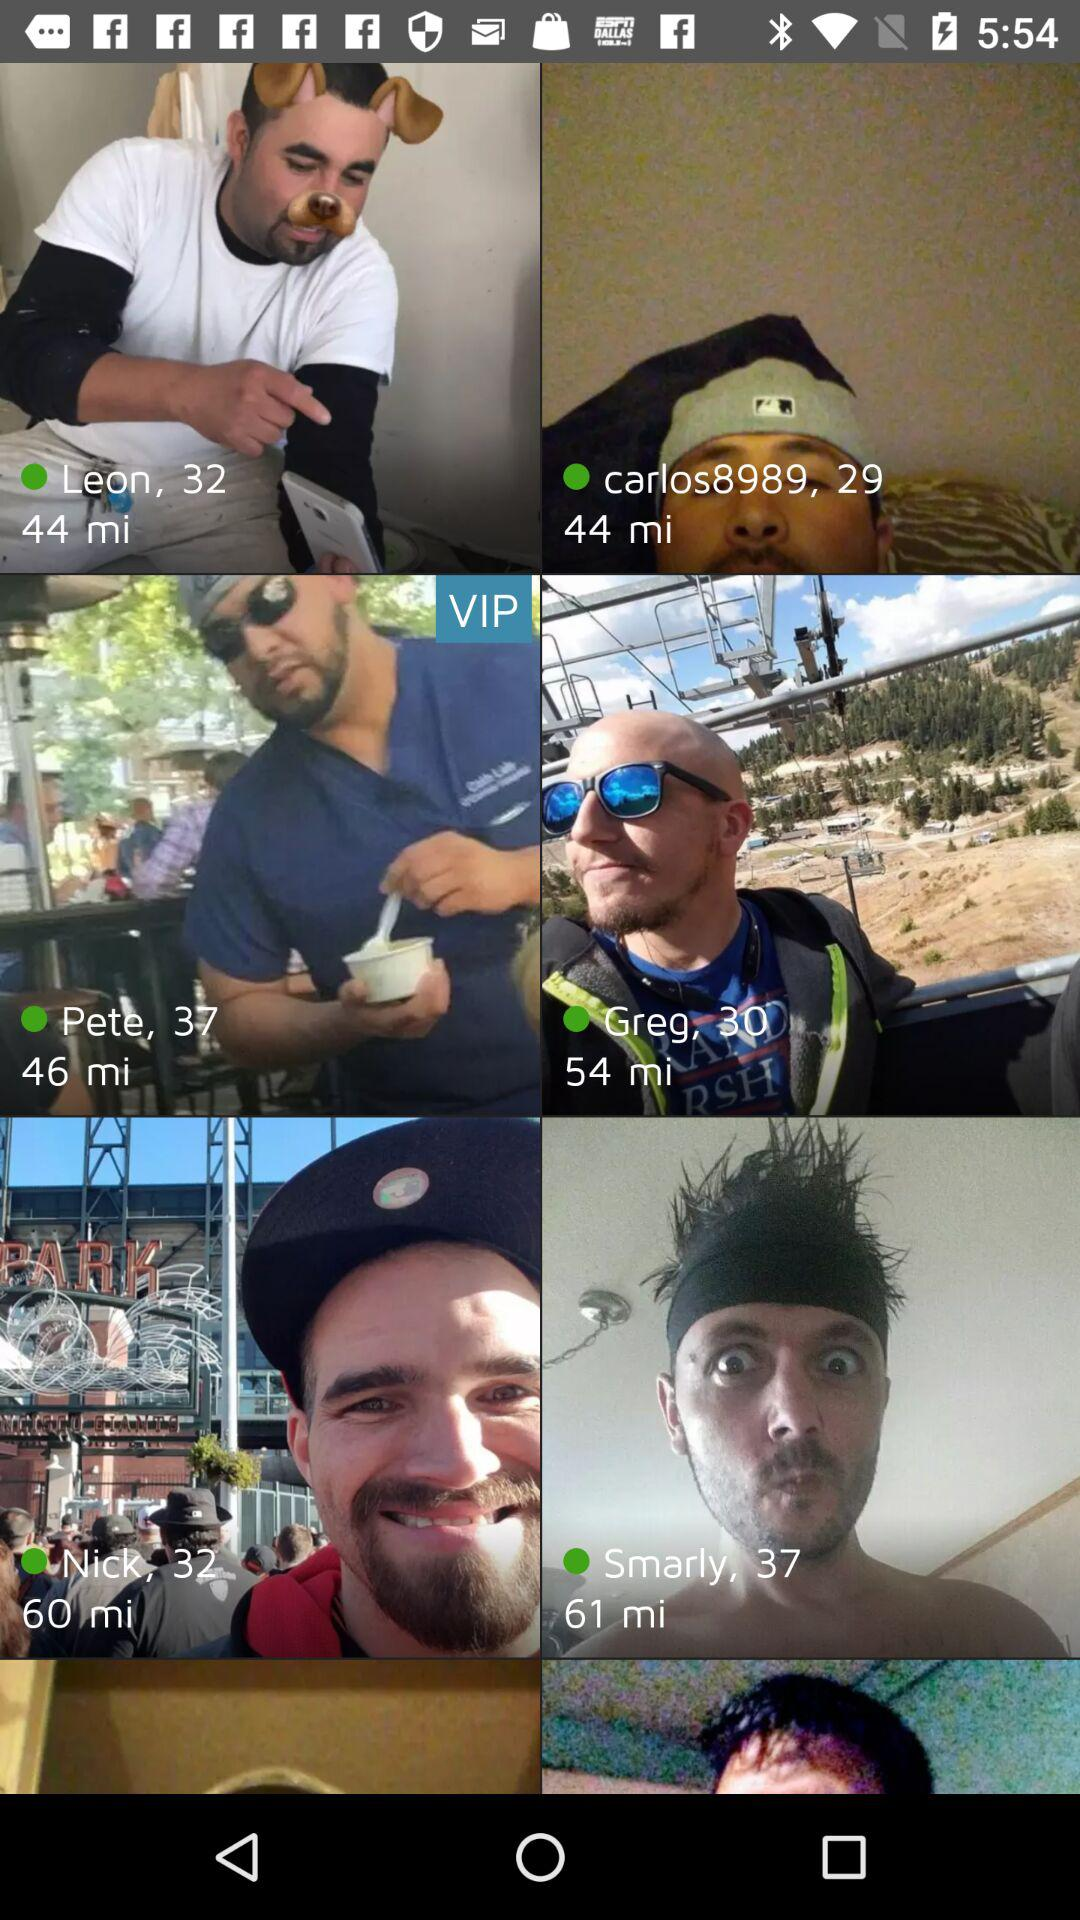What is the age of Greg? Greg is 30 years old. 